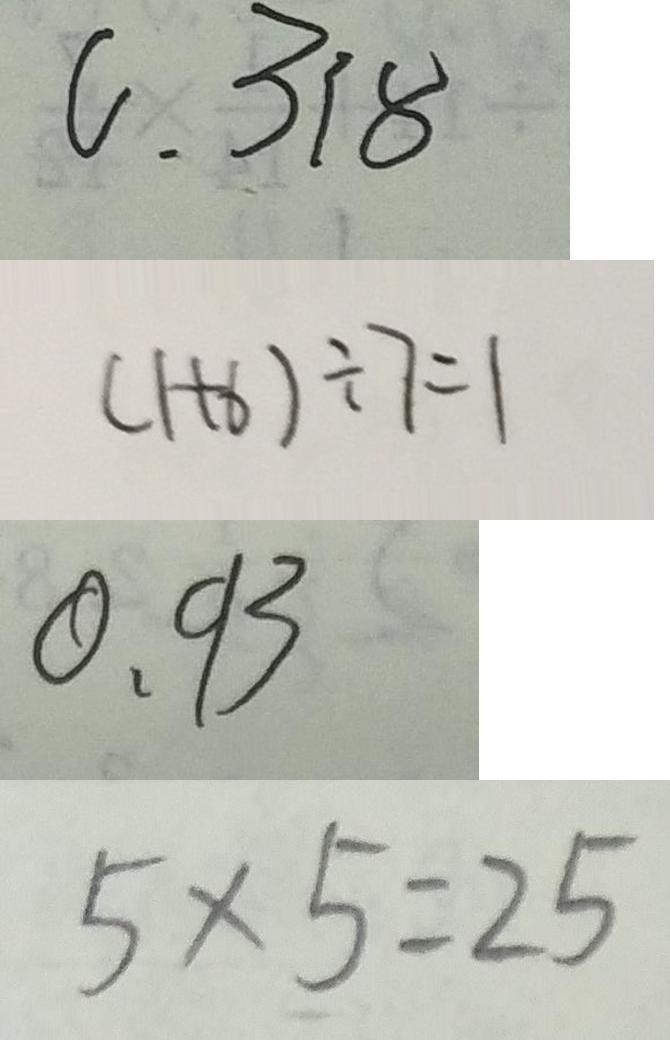Convert formula to latex. <formula><loc_0><loc_0><loc_500><loc_500>0 . 3 1 8 
 ( 1 + 6 ) \div 7 = 1 
 0 . 9 3 
 5 \times 5 = 2 5</formula> 